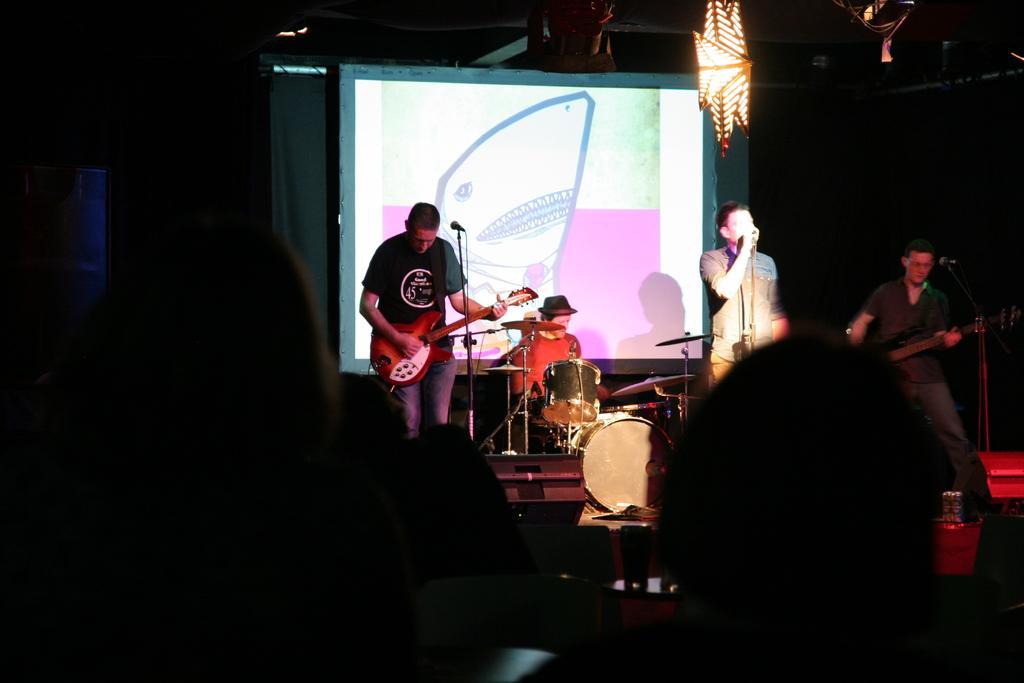Please provide a concise description of this image. In this image,few people are playing musical instrument. At the bottom, human heads are there. At back side, we can see a screen and light at the top of the image. 